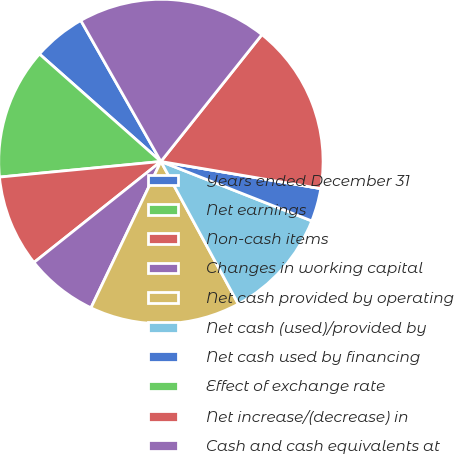Convert chart to OTSL. <chart><loc_0><loc_0><loc_500><loc_500><pie_chart><fcel>Years ended December 31<fcel>Net earnings<fcel>Non-cash items<fcel>Changes in working capital<fcel>Net cash provided by operating<fcel>Net cash (used)/provided by<fcel>Net cash used by financing<fcel>Effect of exchange rate<fcel>Net increase/(decrease) in<fcel>Cash and cash equivalents at<nl><fcel>5.25%<fcel>13.06%<fcel>9.16%<fcel>7.21%<fcel>15.01%<fcel>11.11%<fcel>3.3%<fcel>0.0%<fcel>16.97%<fcel>18.92%<nl></chart> 